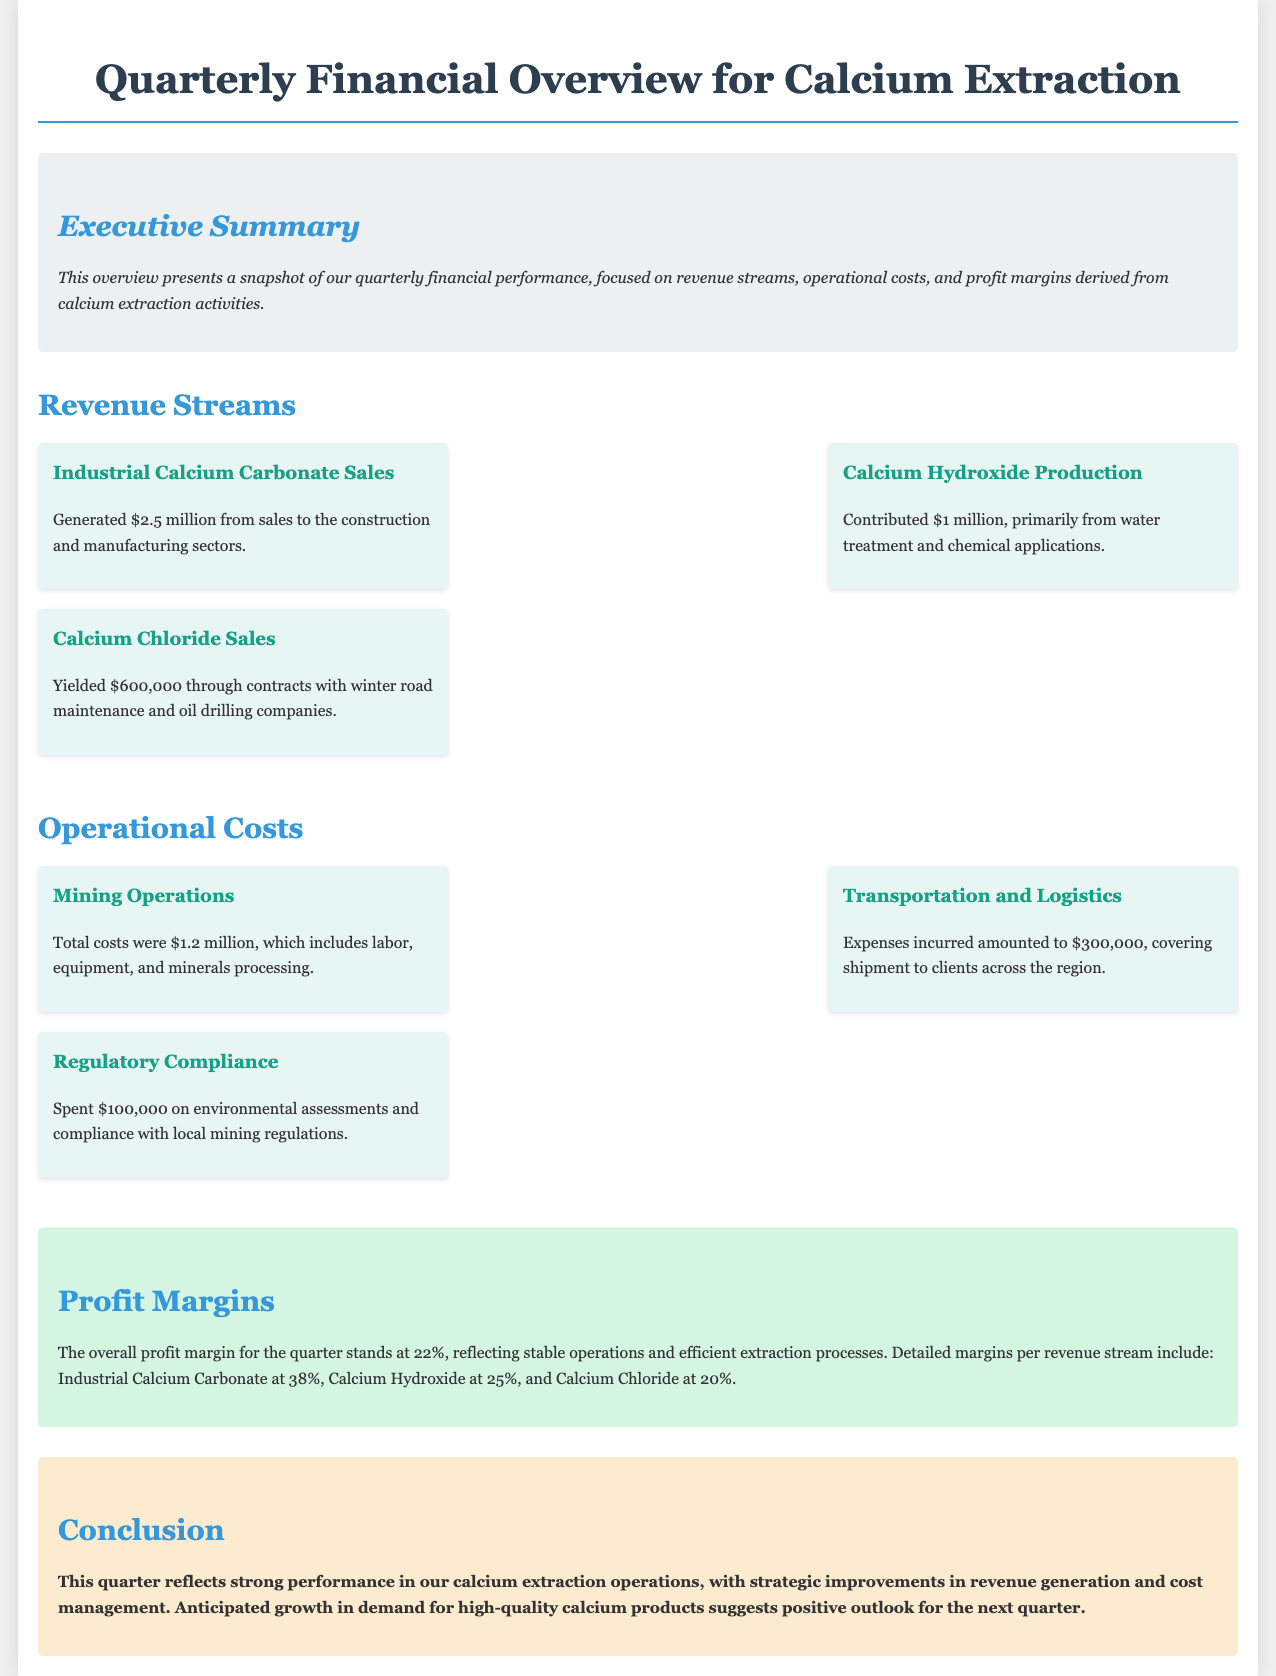What is the total revenue from Industrial Calcium Carbonate Sales? The revenue from Industrial Calcium Carbonate Sales is specified in the document as $2.5 million.
Answer: $2.5 million What are the total operational costs for Mining Operations? The document states that the total costs for Mining Operations were $1.2 million.
Answer: $1.2 million What is the profit margin for Calcium Hydroxide? The document provides that the profit margin for Calcium Hydroxide is 25%.
Answer: 25% How much revenue was generated from Calcium Chloride Sales? According to the document, the revenue from Calcium Chloride Sales is $600,000.
Answer: $600,000 What is the total operational cost related to Transportation and Logistics? The document indicates that expenses for Transportation and Logistics amounted to $300,000.
Answer: $300,000 What is the overall profit margin for the quarter? The document states that the overall profit margin for the quarter stands at 22%.
Answer: 22% What is the contribution of Calcium Hydroxide production to the revenue? The revenue contribution from Calcium Hydroxide production is detailed as $1 million.
Answer: $1 million What is the total revenue from all sources? The total revenue is calculated by summing all revenue streams: $2.5 million + $1 million + $600,000 = $4.1 million.
Answer: $4.1 million What were the regulatory compliance costs? The document indicates that $100,000 was spent on regulatory compliance.
Answer: $100,000 